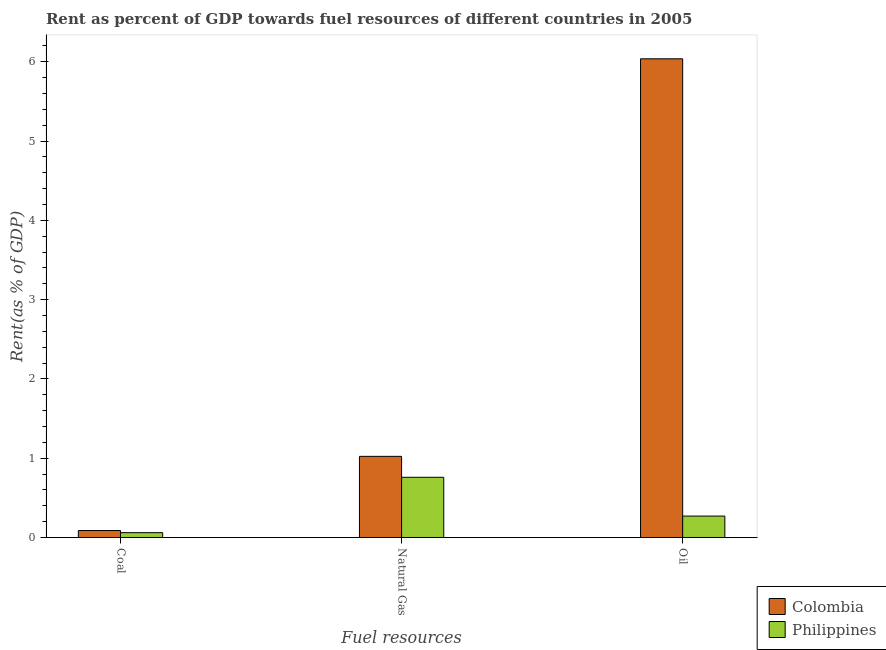How many different coloured bars are there?
Provide a short and direct response. 2. Are the number of bars per tick equal to the number of legend labels?
Provide a short and direct response. Yes. Are the number of bars on each tick of the X-axis equal?
Make the answer very short. Yes. What is the label of the 1st group of bars from the left?
Offer a terse response. Coal. What is the rent towards coal in Colombia?
Your answer should be very brief. 0.09. Across all countries, what is the maximum rent towards coal?
Provide a short and direct response. 0.09. Across all countries, what is the minimum rent towards coal?
Make the answer very short. 0.06. In which country was the rent towards natural gas maximum?
Ensure brevity in your answer.  Colombia. What is the total rent towards coal in the graph?
Provide a short and direct response. 0.15. What is the difference between the rent towards oil in Philippines and that in Colombia?
Make the answer very short. -5.77. What is the difference between the rent towards coal in Colombia and the rent towards oil in Philippines?
Offer a very short reply. -0.18. What is the average rent towards natural gas per country?
Offer a terse response. 0.89. What is the difference between the rent towards coal and rent towards oil in Philippines?
Provide a short and direct response. -0.21. What is the ratio of the rent towards natural gas in Colombia to that in Philippines?
Provide a succinct answer. 1.35. Is the difference between the rent towards oil in Philippines and Colombia greater than the difference between the rent towards natural gas in Philippines and Colombia?
Your response must be concise. No. What is the difference between the highest and the second highest rent towards coal?
Make the answer very short. 0.03. What is the difference between the highest and the lowest rent towards natural gas?
Make the answer very short. 0.26. In how many countries, is the rent towards natural gas greater than the average rent towards natural gas taken over all countries?
Your response must be concise. 1. What does the 1st bar from the left in Oil represents?
Your answer should be compact. Colombia. What does the 2nd bar from the right in Natural Gas represents?
Provide a short and direct response. Colombia. How many bars are there?
Offer a very short reply. 6. Are all the bars in the graph horizontal?
Offer a terse response. No. How many countries are there in the graph?
Your answer should be very brief. 2. Does the graph contain any zero values?
Ensure brevity in your answer.  No. Does the graph contain grids?
Keep it short and to the point. No. Where does the legend appear in the graph?
Ensure brevity in your answer.  Bottom right. How many legend labels are there?
Keep it short and to the point. 2. What is the title of the graph?
Ensure brevity in your answer.  Rent as percent of GDP towards fuel resources of different countries in 2005. Does "Canada" appear as one of the legend labels in the graph?
Offer a very short reply. No. What is the label or title of the X-axis?
Make the answer very short. Fuel resources. What is the label or title of the Y-axis?
Provide a succinct answer. Rent(as % of GDP). What is the Rent(as % of GDP) in Colombia in Coal?
Provide a short and direct response. 0.09. What is the Rent(as % of GDP) of Philippines in Coal?
Offer a terse response. 0.06. What is the Rent(as % of GDP) in Colombia in Natural Gas?
Provide a succinct answer. 1.02. What is the Rent(as % of GDP) of Philippines in Natural Gas?
Provide a succinct answer. 0.76. What is the Rent(as % of GDP) of Colombia in Oil?
Keep it short and to the point. 6.04. What is the Rent(as % of GDP) in Philippines in Oil?
Keep it short and to the point. 0.27. Across all Fuel resources, what is the maximum Rent(as % of GDP) of Colombia?
Offer a very short reply. 6.04. Across all Fuel resources, what is the maximum Rent(as % of GDP) of Philippines?
Your answer should be compact. 0.76. Across all Fuel resources, what is the minimum Rent(as % of GDP) in Colombia?
Ensure brevity in your answer.  0.09. Across all Fuel resources, what is the minimum Rent(as % of GDP) in Philippines?
Keep it short and to the point. 0.06. What is the total Rent(as % of GDP) of Colombia in the graph?
Your response must be concise. 7.15. What is the total Rent(as % of GDP) of Philippines in the graph?
Keep it short and to the point. 1.09. What is the difference between the Rent(as % of GDP) in Colombia in Coal and that in Natural Gas?
Your response must be concise. -0.94. What is the difference between the Rent(as % of GDP) in Philippines in Coal and that in Natural Gas?
Ensure brevity in your answer.  -0.7. What is the difference between the Rent(as % of GDP) of Colombia in Coal and that in Oil?
Offer a very short reply. -5.95. What is the difference between the Rent(as % of GDP) of Philippines in Coal and that in Oil?
Your answer should be compact. -0.21. What is the difference between the Rent(as % of GDP) of Colombia in Natural Gas and that in Oil?
Your answer should be very brief. -5.01. What is the difference between the Rent(as % of GDP) in Philippines in Natural Gas and that in Oil?
Your answer should be compact. 0.49. What is the difference between the Rent(as % of GDP) in Colombia in Coal and the Rent(as % of GDP) in Philippines in Natural Gas?
Provide a succinct answer. -0.67. What is the difference between the Rent(as % of GDP) of Colombia in Coal and the Rent(as % of GDP) of Philippines in Oil?
Make the answer very short. -0.18. What is the difference between the Rent(as % of GDP) of Colombia in Natural Gas and the Rent(as % of GDP) of Philippines in Oil?
Make the answer very short. 0.75. What is the average Rent(as % of GDP) in Colombia per Fuel resources?
Offer a very short reply. 2.38. What is the average Rent(as % of GDP) of Philippines per Fuel resources?
Provide a succinct answer. 0.36. What is the difference between the Rent(as % of GDP) in Colombia and Rent(as % of GDP) in Philippines in Coal?
Offer a terse response. 0.03. What is the difference between the Rent(as % of GDP) in Colombia and Rent(as % of GDP) in Philippines in Natural Gas?
Provide a succinct answer. 0.26. What is the difference between the Rent(as % of GDP) of Colombia and Rent(as % of GDP) of Philippines in Oil?
Offer a very short reply. 5.77. What is the ratio of the Rent(as % of GDP) of Colombia in Coal to that in Natural Gas?
Offer a terse response. 0.09. What is the ratio of the Rent(as % of GDP) of Philippines in Coal to that in Natural Gas?
Make the answer very short. 0.08. What is the ratio of the Rent(as % of GDP) of Colombia in Coal to that in Oil?
Give a very brief answer. 0.01. What is the ratio of the Rent(as % of GDP) of Philippines in Coal to that in Oil?
Offer a terse response. 0.23. What is the ratio of the Rent(as % of GDP) of Colombia in Natural Gas to that in Oil?
Offer a terse response. 0.17. What is the ratio of the Rent(as % of GDP) of Philippines in Natural Gas to that in Oil?
Keep it short and to the point. 2.81. What is the difference between the highest and the second highest Rent(as % of GDP) of Colombia?
Your response must be concise. 5.01. What is the difference between the highest and the second highest Rent(as % of GDP) of Philippines?
Offer a very short reply. 0.49. What is the difference between the highest and the lowest Rent(as % of GDP) of Colombia?
Offer a very short reply. 5.95. What is the difference between the highest and the lowest Rent(as % of GDP) in Philippines?
Provide a succinct answer. 0.7. 